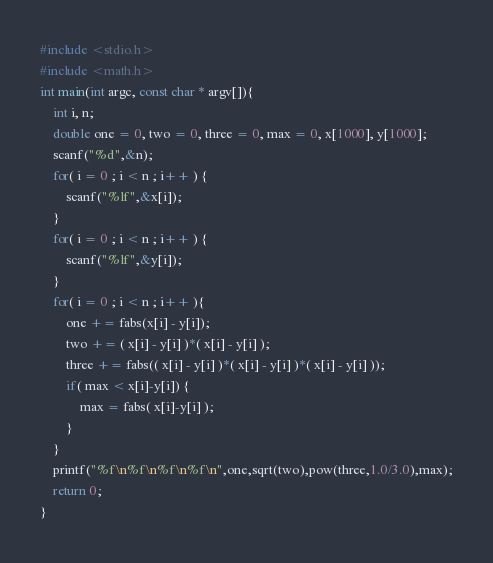Convert code to text. <code><loc_0><loc_0><loc_500><loc_500><_C_>#include <stdio.h>
#include <math.h>
int main(int argc, const char * argv[]){
    int i, n;
    double one = 0, two = 0, three = 0, max = 0, x[1000], y[1000];
    scanf("%d",&n);
    for( i = 0 ; i < n ; i++ ) {
        scanf("%lf",&x[i]);
    }
    for( i = 0 ; i < n ; i++ ) {
        scanf("%lf",&y[i]);
    }
    for( i = 0 ; i < n ; i++ ){
        one += fabs(x[i] - y[i]);
        two += ( x[i] - y[i] )*( x[i] - y[i] );
        three += fabs(( x[i] - y[i] )*( x[i] - y[i] )*( x[i] - y[i] ));
        if( max < x[i]-y[i]) {
            max = fabs( x[i]-y[i] );
        }
    }
    printf("%f\n%f\n%f\n%f\n",one,sqrt(two),pow(three,1.0/3.0),max);
    return 0;
}</code> 